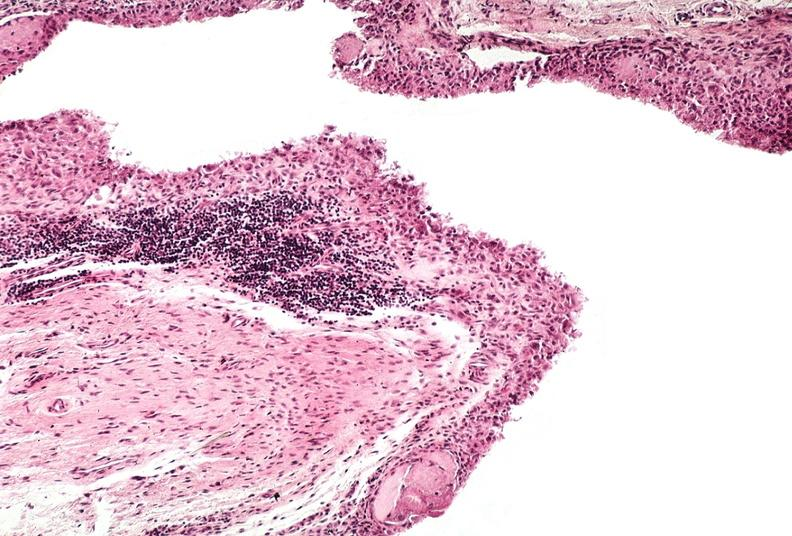what does this image show?
Answer the question using a single word or phrase. Synovial proliferation 